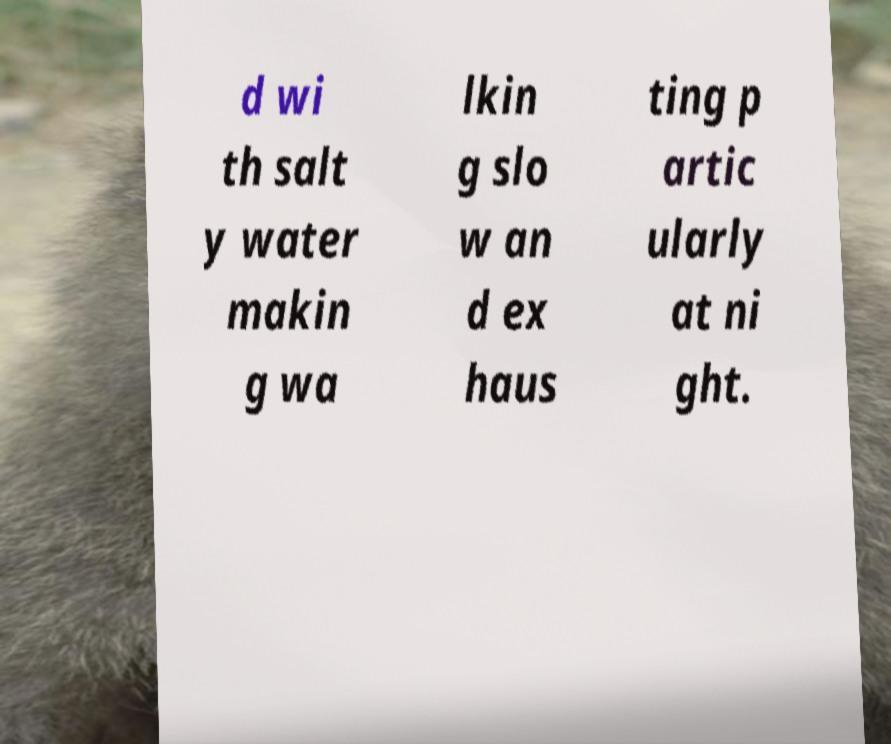There's text embedded in this image that I need extracted. Can you transcribe it verbatim? d wi th salt y water makin g wa lkin g slo w an d ex haus ting p artic ularly at ni ght. 